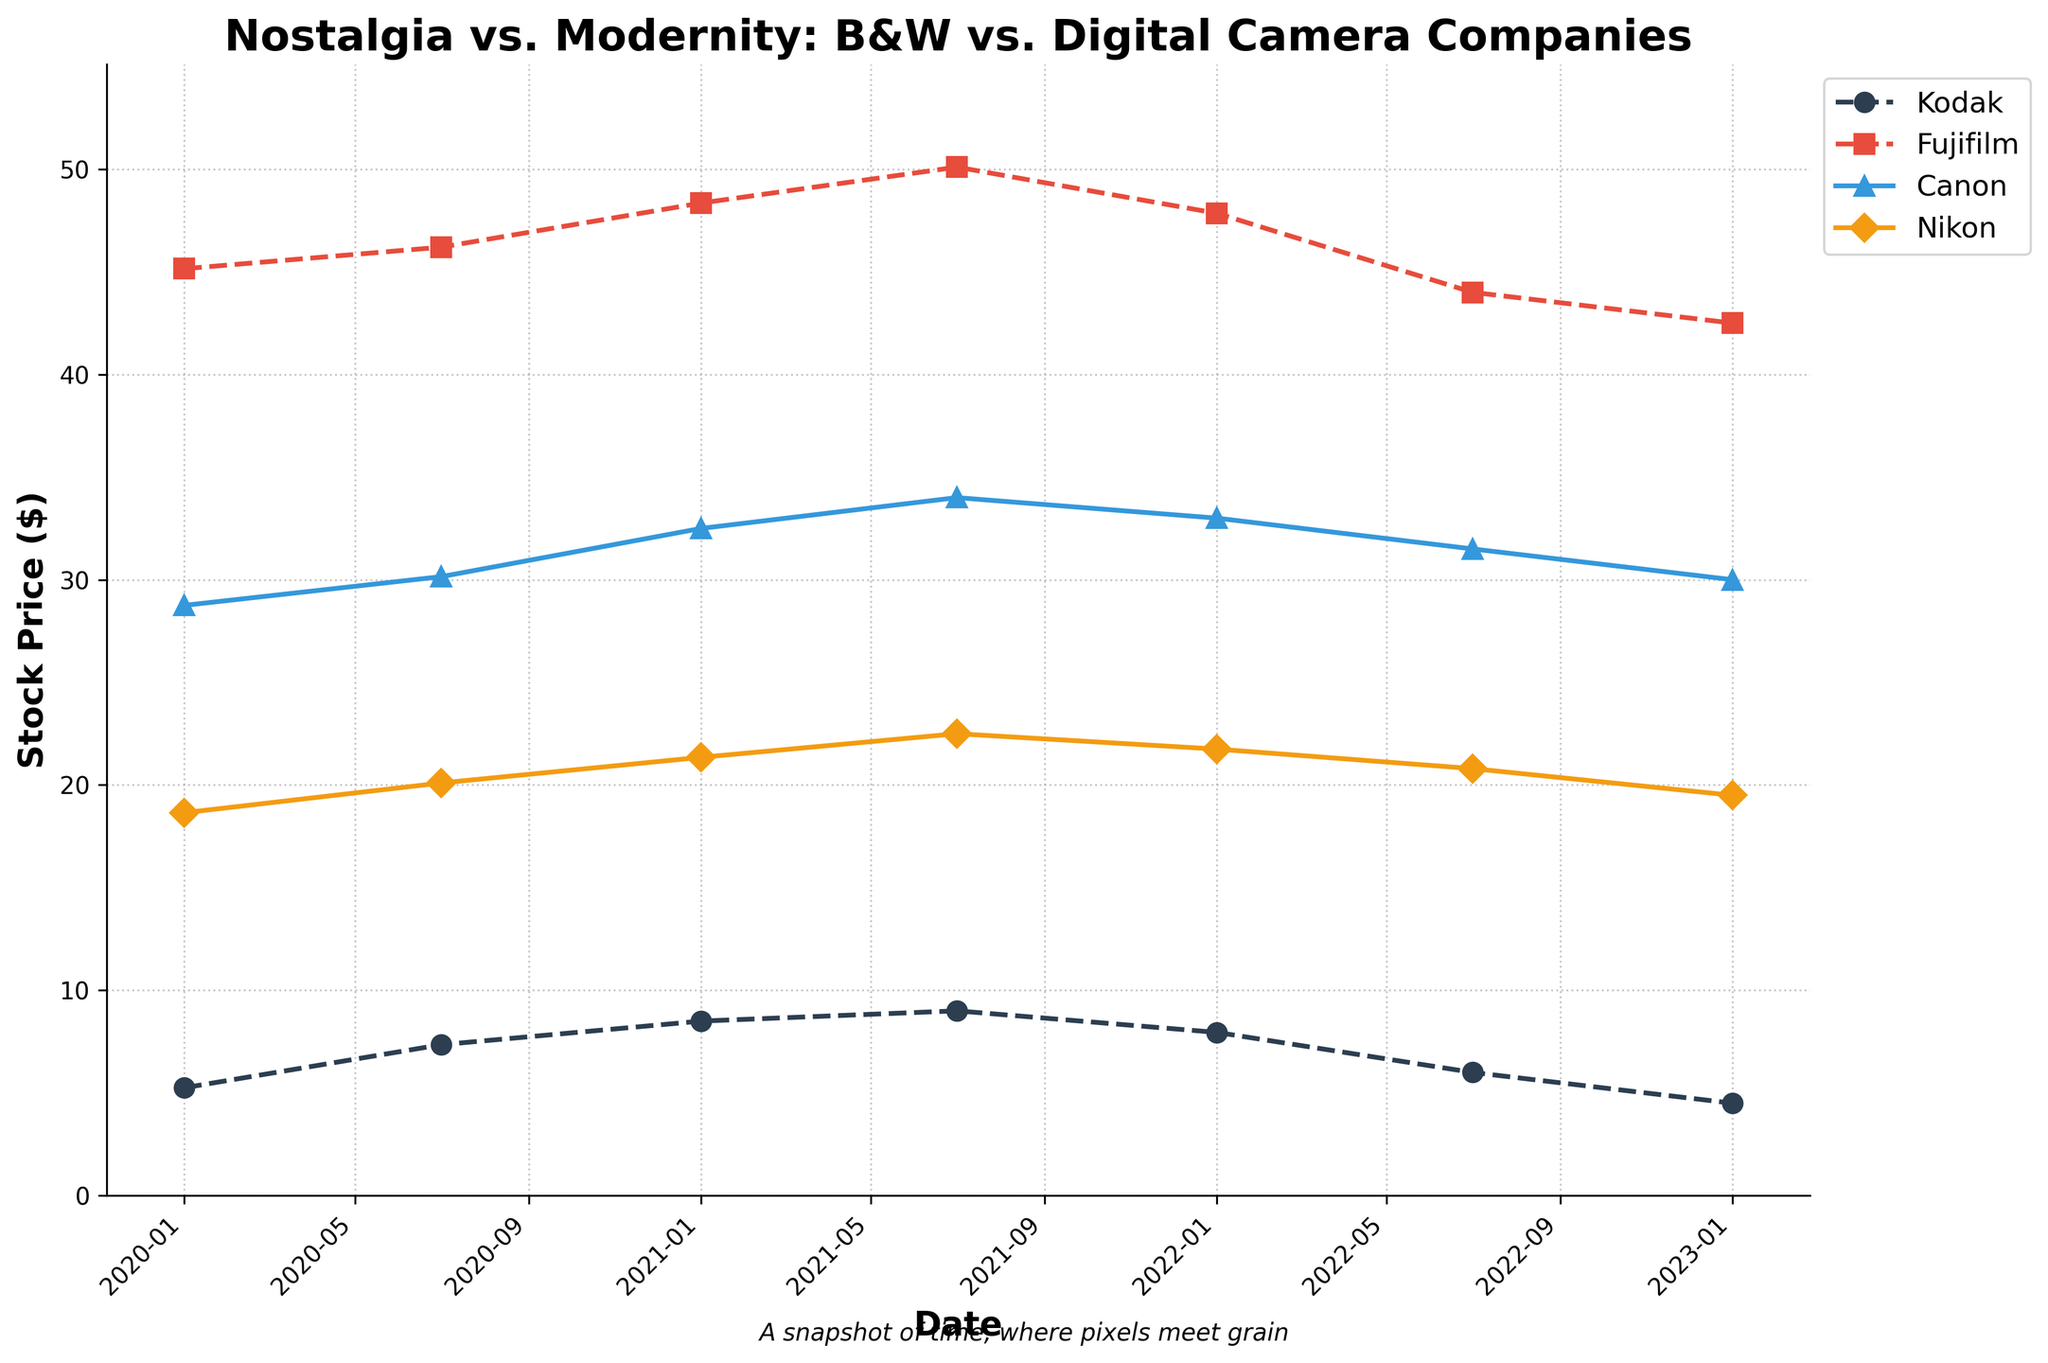What is the stock price of Kodak on January 1, 2021? Look at the plot for the line representing Kodak and find the data point corresponding to January 1, 2021.
Answer: 8.50 Between Kodak and Canon, which company had a higher stock price in July 2021? Compare the data points for Kodak and Canon in July 2021 from the plot. Kodak's price is marked near 9.00 and Canon's is near 34.00.
Answer: Canon What is the overall trend for Fujifilm's stock price from 2020 to 2023? Observe the line representing Fujifilm from 2020 to 2023. The price generally decreases from around 45.15 to 42.50, though there are fluctuations.
Answer: Decreasing What is the difference between the highest stock price of Nikon and the lowest stock price of Kodak within the given period? The highest stock price of Nikon is 22.50 (July 2021) and the lowest stock price of Kodak is 4.50 (January 2023). Calculate the difference: 22.50 - 4.50 = 18.00.
Answer: 18.00 Which company has more stable stock prices, Kodak or Nikon, and what indicates this? Compare the fluctuations in the stock prices of Kodak and Nikon. Kodak shows more variability, reaching highs and lows between 4.50 and 9.00, while Nikon has smaller fluctuations between 18.65 and 22.50.
Answer: Nikon How does the stock price trend of digital camera companies (Canon and Nikon) differ from black-and-white companies (Kodak and Fujifilm)? Compare the lines for Canon and Nikon with those for Kodak and Fujifilm. Both digital camera companies show less dramatic annual changes and a gentle decrease, while black-and-white companies show more significant fluctuations.
Answer: Less variable for digital What are the stock prices of Fujifilm and Nikon when they are at their peak within the given period? Identify the highest point on Fujifilm's line and Nikon's line from the plot. Fujifilm peaks at 50.10 (July 2021) and Nikon peaks at 22.50 (July 2021).
Answer: 50.10 and 22.50 What is the average stock price for Canon over the observed period? Sum Canon’s stock prices: 28.75 + 30.15 + 32.50 + 34.00 + 33.00 + 31.50 + 30.00 = 220.90. Divide by the number of data points, which is 7. 220.90 / 7 ≈ 31.56.
Answer: 31.56 Compare the highest stock prices of Fujifilm and Canon. Which one is greater, and by how much? Fujifilm's highest price is 50.10, and Canon's highest price is 34.00. The difference is 50.10 - 34.00 = 16.10. Fujifilm's is greater.
Answer: Fujifilm by 16.10 How has the stock price of Kodak changed from the first date to the last date in the dataset? Compare Kodak's stock price on January 1, 2020 (5.25) with that on January 1, 2023 (4.50). Calculate the difference: 5.25 - 4.50 = 0.75.
Answer: Decreased by 0.75 